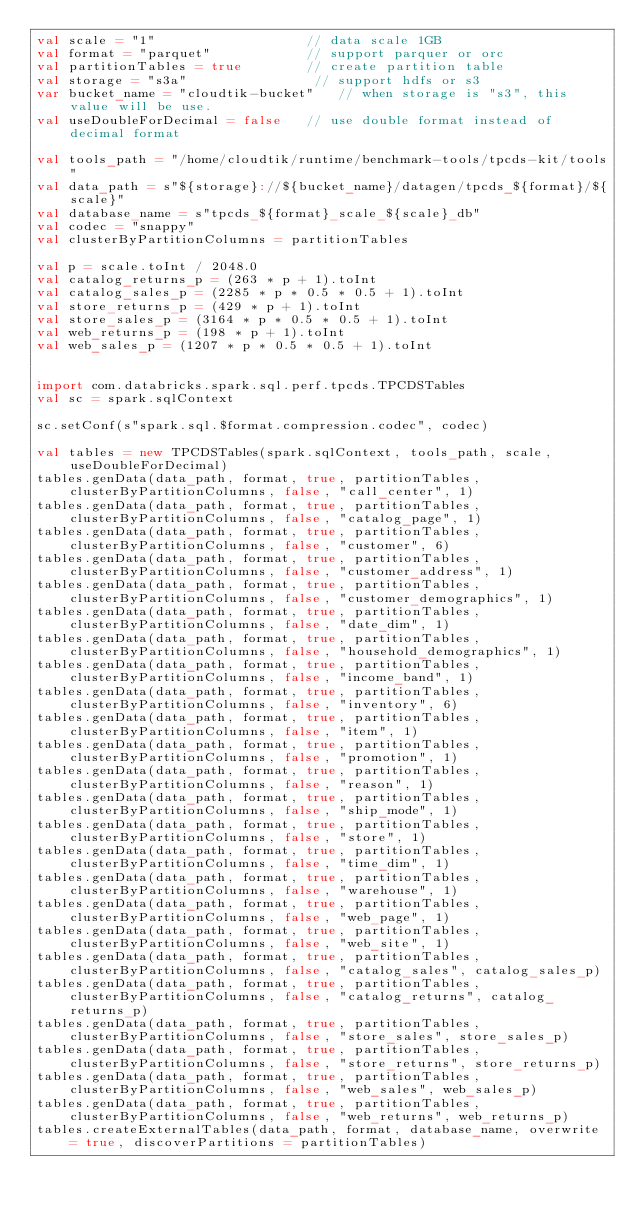Convert code to text. <code><loc_0><loc_0><loc_500><loc_500><_Scala_>val scale = "1"                   // data scale 1GB
val format = "parquet"            // support parquer or orc
val partitionTables = true        // create partition table
val storage = "s3a"                // support hdfs or s3
var bucket_name = "cloudtik-bucket"   // when storage is "s3", this value will be use.
val useDoubleForDecimal = false   // use double format instead of decimal format

val tools_path = "/home/cloudtik/runtime/benchmark-tools/tpcds-kit/tools"
val data_path = s"${storage}://${bucket_name}/datagen/tpcds_${format}/${scale}"
val database_name = s"tpcds_${format}_scale_${scale}_db"
val codec = "snappy"
val clusterByPartitionColumns = partitionTables

val p = scale.toInt / 2048.0
val catalog_returns_p = (263 * p + 1).toInt
val catalog_sales_p = (2285 * p * 0.5 * 0.5 + 1).toInt
val store_returns_p = (429 * p + 1).toInt
val store_sales_p = (3164 * p * 0.5 * 0.5 + 1).toInt
val web_returns_p = (198 * p + 1).toInt
val web_sales_p = (1207 * p * 0.5 * 0.5 + 1).toInt


import com.databricks.spark.sql.perf.tpcds.TPCDSTables
val sc = spark.sqlContext

sc.setConf(s"spark.sql.$format.compression.codec", codec)

val tables = new TPCDSTables(spark.sqlContext, tools_path, scale, useDoubleForDecimal)
tables.genData(data_path, format, true, partitionTables, clusterByPartitionColumns, false, "call_center", 1)
tables.genData(data_path, format, true, partitionTables, clusterByPartitionColumns, false, "catalog_page", 1)
tables.genData(data_path, format, true, partitionTables, clusterByPartitionColumns, false, "customer", 6)
tables.genData(data_path, format, true, partitionTables, clusterByPartitionColumns, false, "customer_address", 1)
tables.genData(data_path, format, true, partitionTables, clusterByPartitionColumns, false, "customer_demographics", 1)
tables.genData(data_path, format, true, partitionTables, clusterByPartitionColumns, false, "date_dim", 1)
tables.genData(data_path, format, true, partitionTables, clusterByPartitionColumns, false, "household_demographics", 1)
tables.genData(data_path, format, true, partitionTables, clusterByPartitionColumns, false, "income_band", 1)
tables.genData(data_path, format, true, partitionTables, clusterByPartitionColumns, false, "inventory", 6)
tables.genData(data_path, format, true, partitionTables, clusterByPartitionColumns, false, "item", 1)
tables.genData(data_path, format, true, partitionTables, clusterByPartitionColumns, false, "promotion", 1)
tables.genData(data_path, format, true, partitionTables, clusterByPartitionColumns, false, "reason", 1)
tables.genData(data_path, format, true, partitionTables, clusterByPartitionColumns, false, "ship_mode", 1)
tables.genData(data_path, format, true, partitionTables, clusterByPartitionColumns, false, "store", 1)
tables.genData(data_path, format, true, partitionTables, clusterByPartitionColumns, false, "time_dim", 1)
tables.genData(data_path, format, true, partitionTables, clusterByPartitionColumns, false, "warehouse", 1)
tables.genData(data_path, format, true, partitionTables, clusterByPartitionColumns, false, "web_page", 1)
tables.genData(data_path, format, true, partitionTables, clusterByPartitionColumns, false, "web_site", 1)
tables.genData(data_path, format, true, partitionTables, clusterByPartitionColumns, false, "catalog_sales", catalog_sales_p)
tables.genData(data_path, format, true, partitionTables, clusterByPartitionColumns, false, "catalog_returns", catalog_returns_p)
tables.genData(data_path, format, true, partitionTables, clusterByPartitionColumns, false, "store_sales", store_sales_p)
tables.genData(data_path, format, true, partitionTables, clusterByPartitionColumns, false, "store_returns", store_returns_p)
tables.genData(data_path, format, true, partitionTables, clusterByPartitionColumns, false, "web_sales", web_sales_p)
tables.genData(data_path, format, true, partitionTables, clusterByPartitionColumns, false, "web_returns", web_returns_p)
tables.createExternalTables(data_path, format, database_name, overwrite = true, discoverPartitions = partitionTables)
</code> 